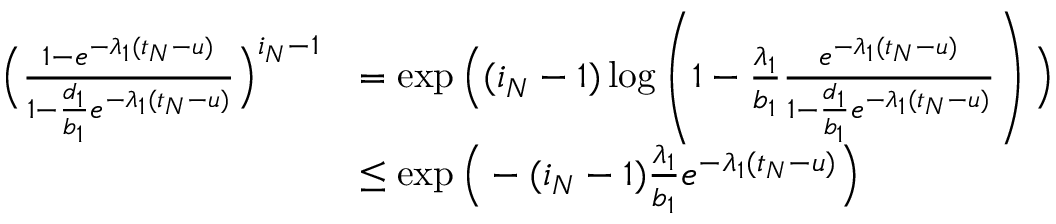<formula> <loc_0><loc_0><loc_500><loc_500>\begin{array} { r l } { \left ( \frac { 1 - e ^ { - \lambda _ { 1 } ( t _ { N } - u ) } } { 1 - \frac { d _ { 1 } } { b _ { 1 } } e ^ { - \lambda _ { 1 } ( t _ { N } - u ) } } \right ) ^ { i _ { N } - 1 } } & { = \exp \left ( ( i _ { N } - 1 ) \log \left ( 1 - \frac { \lambda _ { 1 } } { b _ { 1 } } \frac { e ^ { - \lambda _ { 1 } ( t _ { N } - u ) } } { 1 - \frac { d _ { 1 } } { b _ { 1 } } e ^ { - \lambda _ { 1 } ( t _ { N } - u ) } } \right ) \right ) } \\ & { \leq \exp \left ( - ( i _ { N } - 1 ) \frac { \lambda _ { 1 } } { b _ { 1 } } e ^ { - \lambda _ { 1 } ( t _ { N } - u ) } \right ) } \end{array}</formula> 